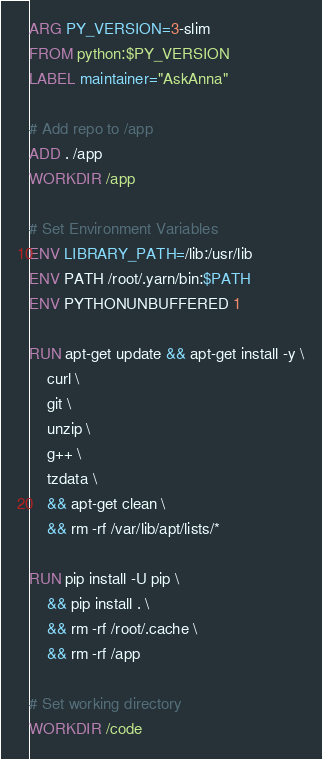Convert code to text. <code><loc_0><loc_0><loc_500><loc_500><_Dockerfile_>ARG PY_VERSION=3-slim
FROM python:$PY_VERSION
LABEL maintainer="AskAnna"

# Add repo to /app
ADD . /app
WORKDIR /app

# Set Environment Variables
ENV LIBRARY_PATH=/lib:/usr/lib
ENV PATH /root/.yarn/bin:$PATH
ENV PYTHONUNBUFFERED 1

RUN apt-get update && apt-get install -y \
    curl \
    git \
    unzip \
    g++ \
    tzdata \
    && apt-get clean \
    && rm -rf /var/lib/apt/lists/*

RUN pip install -U pip \
    && pip install . \
    && rm -rf /root/.cache \
    && rm -rf /app

# Set working directory
WORKDIR /code
</code> 